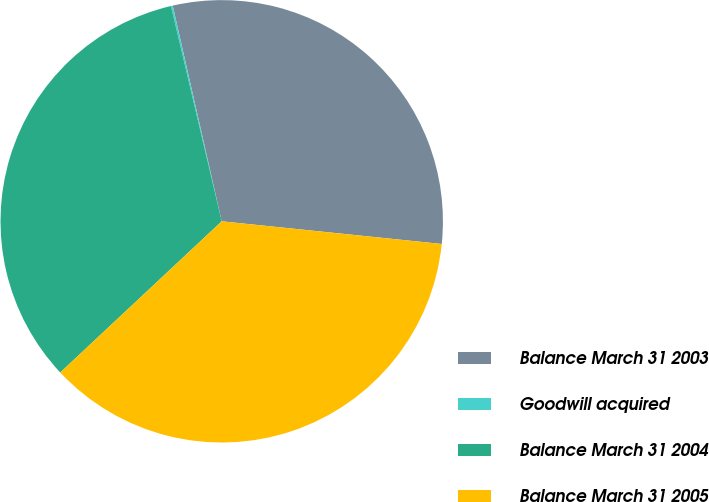<chart> <loc_0><loc_0><loc_500><loc_500><pie_chart><fcel>Balance March 31 2003<fcel>Goodwill acquired<fcel>Balance March 31 2004<fcel>Balance March 31 2005<nl><fcel>30.19%<fcel>0.13%<fcel>33.29%<fcel>36.39%<nl></chart> 